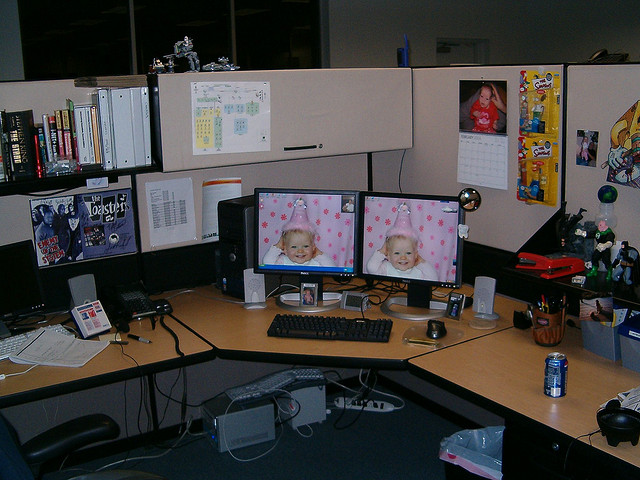Read all the text in this image. Toastei 